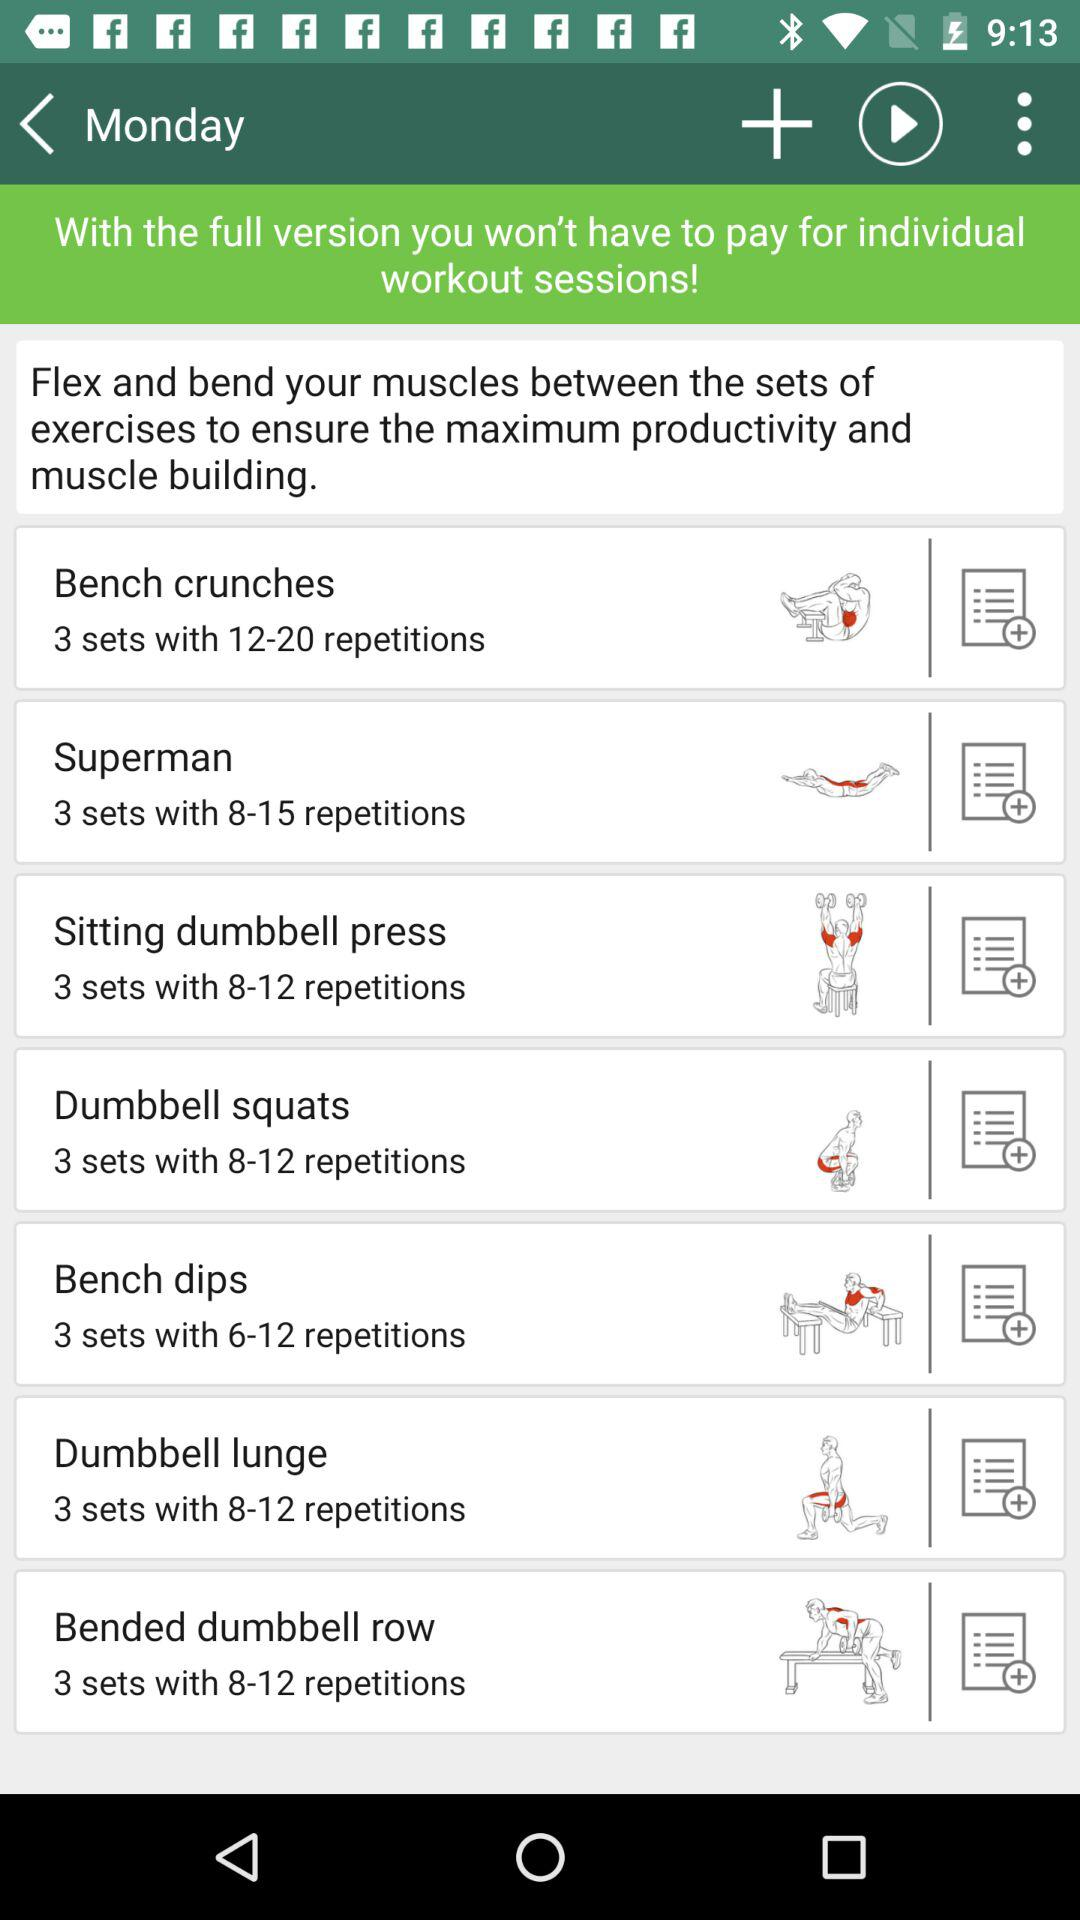How many sets do I have to do of the "Dumbbell lunge"? You have to do 3 sets. 